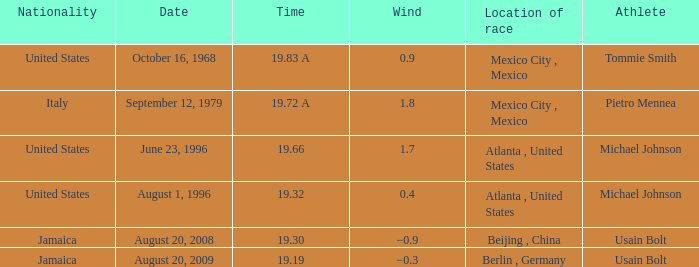Would you mind parsing the complete table? {'header': ['Nationality', 'Date', 'Time', 'Wind', 'Location of race', 'Athlete'], 'rows': [['United States', 'October 16, 1968', '19.83 A', '0.9', 'Mexico City , Mexico', 'Tommie Smith'], ['Italy', 'September 12, 1979', '19.72 A', '1.8', 'Mexico City , Mexico', 'Pietro Mennea'], ['United States', 'June 23, 1996', '19.66', '1.7', 'Atlanta , United States', 'Michael Johnson'], ['United States', 'August 1, 1996', '19.32', '0.4', 'Atlanta , United States', 'Michael Johnson'], ['Jamaica', 'August 20, 2008', '19.30', '−0.9', 'Beijing , China', 'Usain Bolt'], ['Jamaica', 'August 20, 2009', '19.19', '−0.3', 'Berlin , Germany', 'Usain Bolt']]} What's the wind when the time was 19.32? 0.4. 